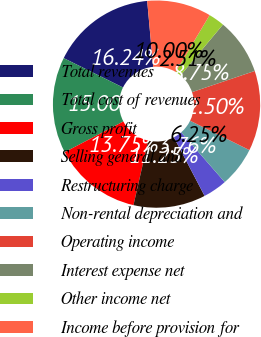Convert chart to OTSL. <chart><loc_0><loc_0><loc_500><loc_500><pie_chart><fcel>Total revenues<fcel>Total cost of revenues<fcel>Gross profit<fcel>Selling general and<fcel>Restructuring charge<fcel>Non-rental depreciation and<fcel>Operating income<fcel>Interest expense net<fcel>Other income net<fcel>Income before provision for<nl><fcel>16.24%<fcel>15.0%<fcel>13.75%<fcel>11.25%<fcel>3.76%<fcel>6.25%<fcel>12.5%<fcel>8.75%<fcel>2.51%<fcel>10.0%<nl></chart> 